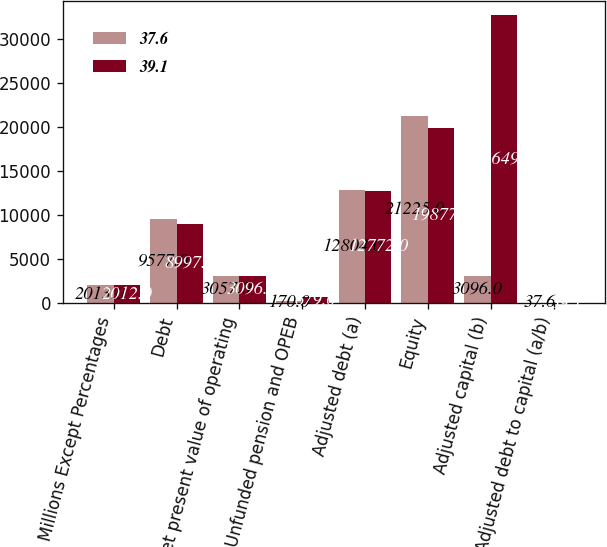Convert chart to OTSL. <chart><loc_0><loc_0><loc_500><loc_500><stacked_bar_chart><ecel><fcel>Millions Except Percentages<fcel>Debt<fcel>Net present value of operating<fcel>Unfunded pension and OPEB<fcel>Adjusted debt (a)<fcel>Equity<fcel>Adjusted capital (b)<fcel>Adjusted debt to capital (a/b)<nl><fcel>37.6<fcel>2013<fcel>9577<fcel>3057<fcel>170<fcel>12804<fcel>21225<fcel>3096<fcel>37.6<nl><fcel>39.1<fcel>2012<fcel>8997<fcel>3096<fcel>679<fcel>12772<fcel>19877<fcel>32649<fcel>39.1<nl></chart> 